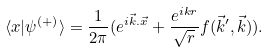<formula> <loc_0><loc_0><loc_500><loc_500>\langle x | \psi ^ { ( + ) } \rangle = \frac { 1 } { 2 \pi } ( e ^ { i \vec { k } . \vec { x } } + \frac { e ^ { i k r } } { \sqrt { r } } f ( \vec { k } ^ { \prime } , \vec { k } ) ) .</formula> 